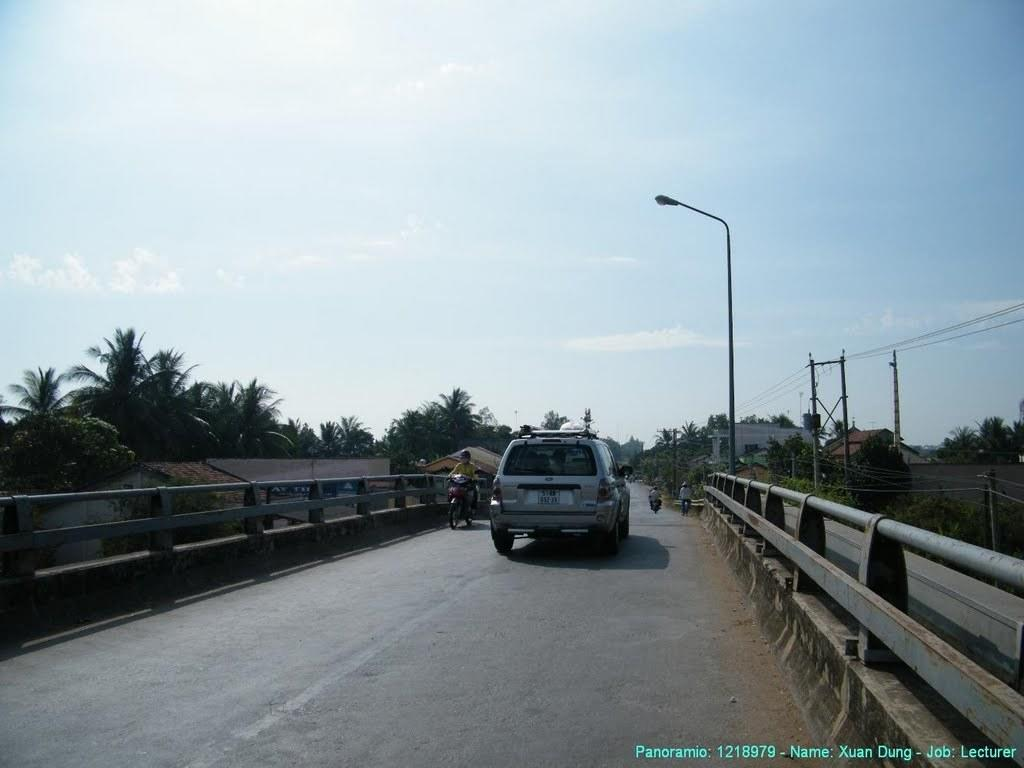What is the person in the image doing? The person is sitting and riding a bike in the image. What else can be seen on the road in the image? There is a car on the road in the image. What is the source of light visible in the image? There is a light on a pole in the image. What type of vegetation is visible in the background? There are trees in the background of the image. What type of structures are visible in the background? There are houses in the background of the image. What else can be seen in the background of the image? There are poles with wires in the background of the image. What is visible above the background in the image? The sky is visible in the background of the image. What type of chalk is being used to draw on the road in the image? There is no chalk or drawing on the road in the image. Can you see any rats running around in the image? There are no rats visible in the image. 